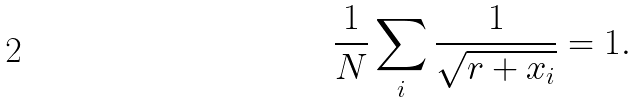<formula> <loc_0><loc_0><loc_500><loc_500>\frac { 1 } { N } \sum _ { i } \frac { 1 } { \sqrt { r + x _ { i } } } = 1 .</formula> 